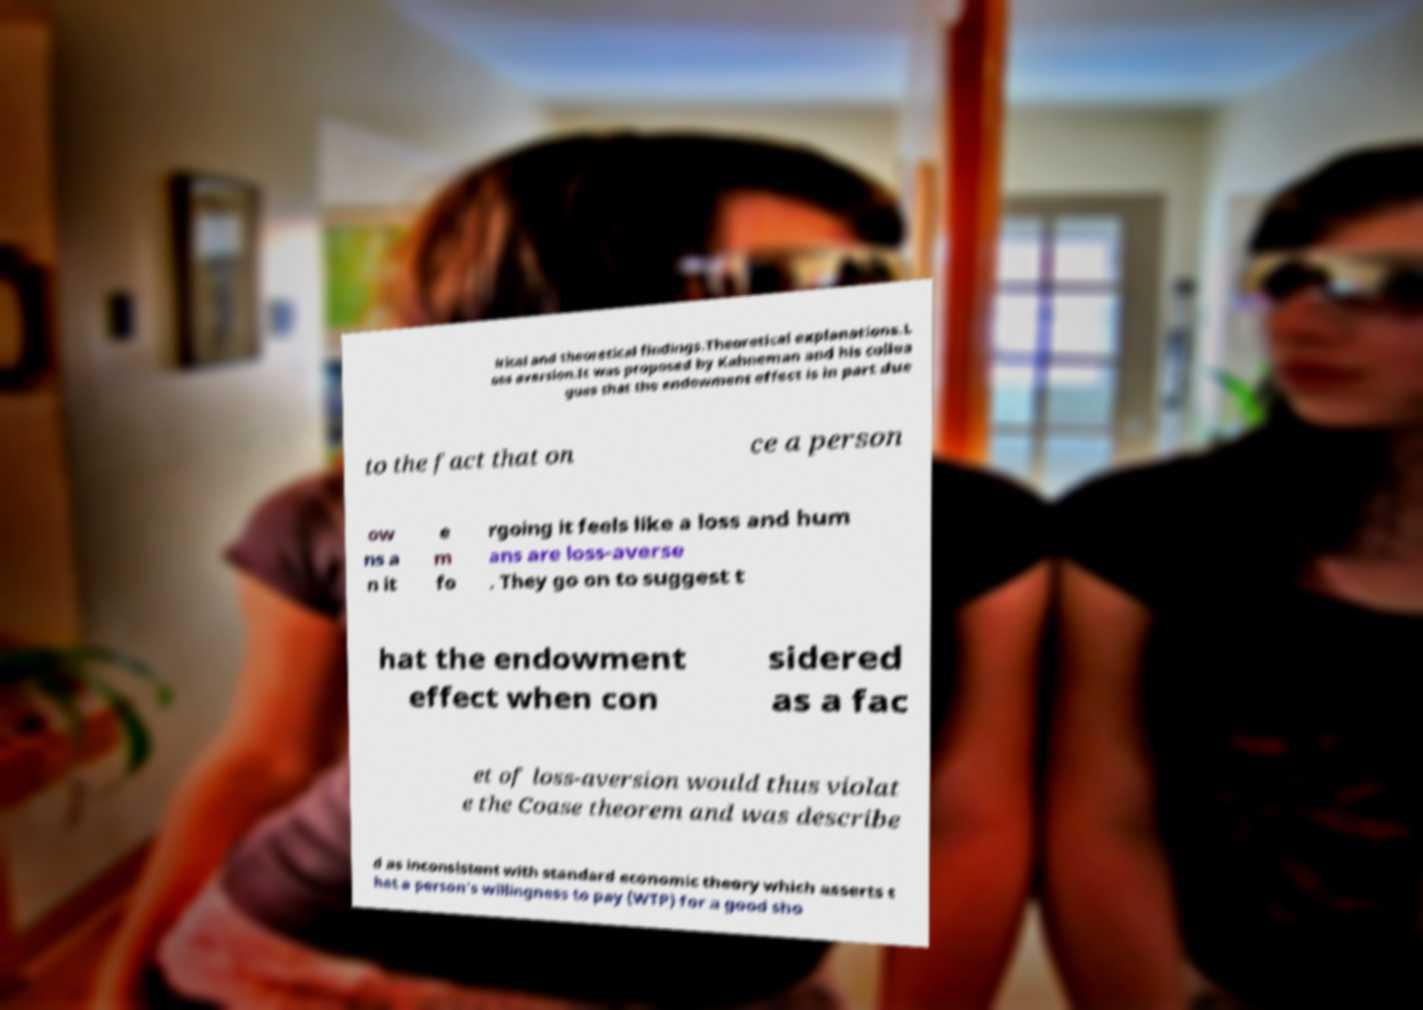Please identify and transcribe the text found in this image. irical and theoretical findings.Theoretical explanations.L oss aversion.It was proposed by Kahneman and his collea gues that the endowment effect is in part due to the fact that on ce a person ow ns a n it e m fo rgoing it feels like a loss and hum ans are loss-averse . They go on to suggest t hat the endowment effect when con sidered as a fac et of loss-aversion would thus violat e the Coase theorem and was describe d as inconsistent with standard economic theory which asserts t hat a person's willingness to pay (WTP) for a good sho 